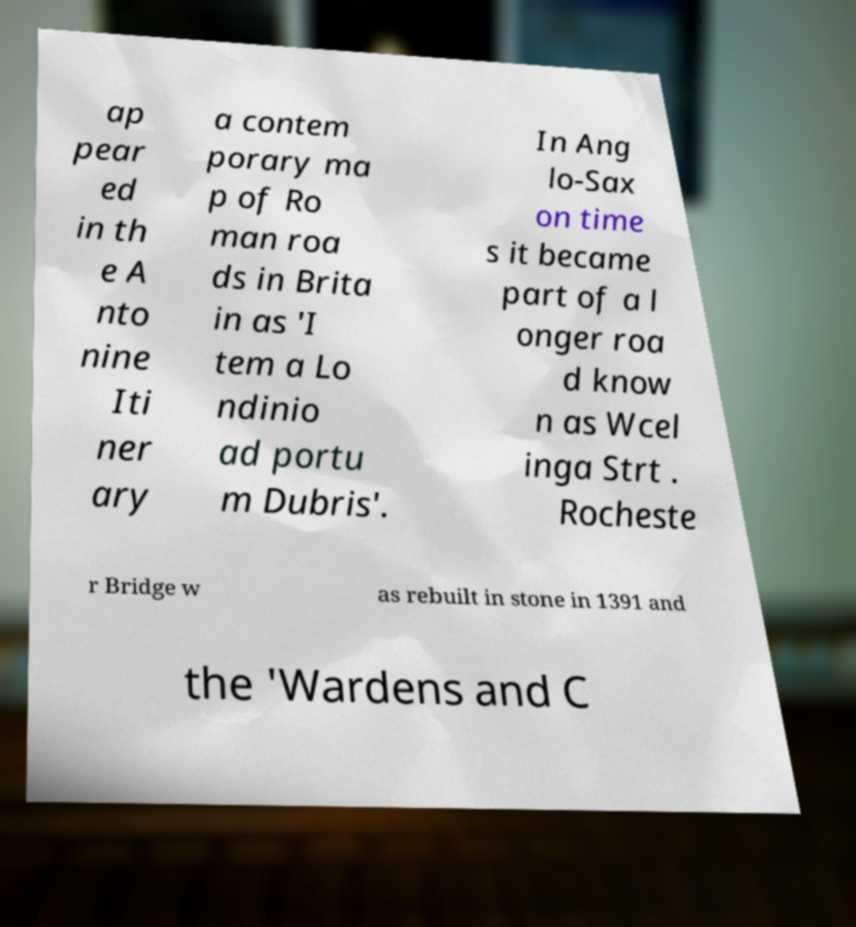Could you extract and type out the text from this image? ap pear ed in th e A nto nine Iti ner ary a contem porary ma p of Ro man roa ds in Brita in as 'I tem a Lo ndinio ad portu m Dubris'. In Ang lo-Sax on time s it became part of a l onger roa d know n as Wcel inga Strt . Rocheste r Bridge w as rebuilt in stone in 1391 and the 'Wardens and C 